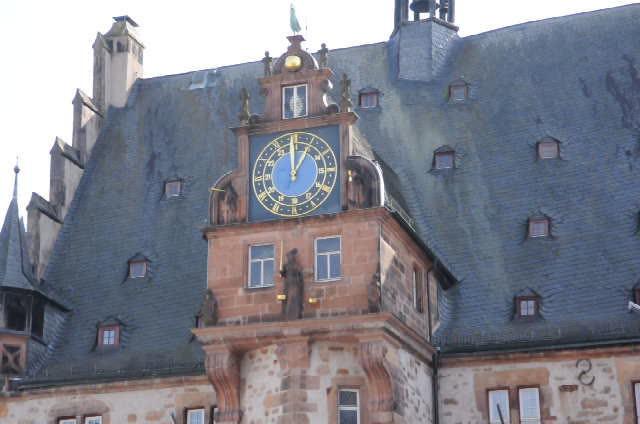What color is the roof?
Be succinct. Blue. What time is the clock showing?
Give a very brief answer. 1:00. How many windows are in the roof?
Concise answer only. 10. 